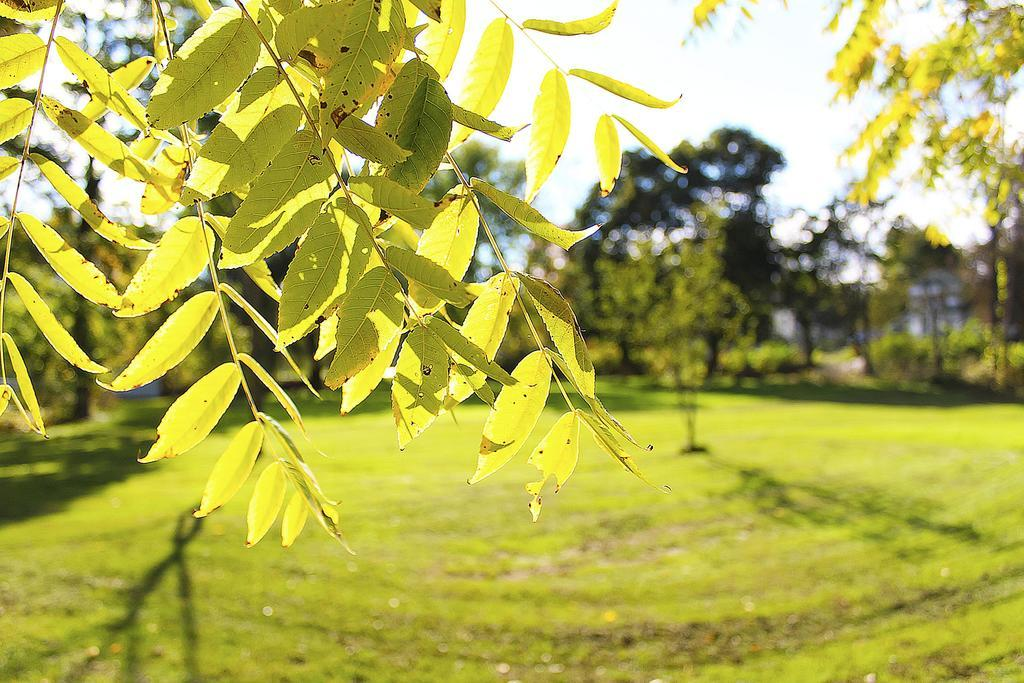What type of natural surface can be seen at the bottom of the image? The surface of the grass is visible at the bottom of the image. What is located at the center of the image? There are trees at the center of the image. What part of the trees can be seen at the top of the image? Leaves of a tree are visible at the top of the image. Can you see a can of soda on the grass in the image? There is no can of soda present in the image; it only features grass, trees, and leaves. Are there any people wearing jeans in the image? There is no mention of people or jeans in the image, as it focuses on natural elements like grass, trees, and leaves. 